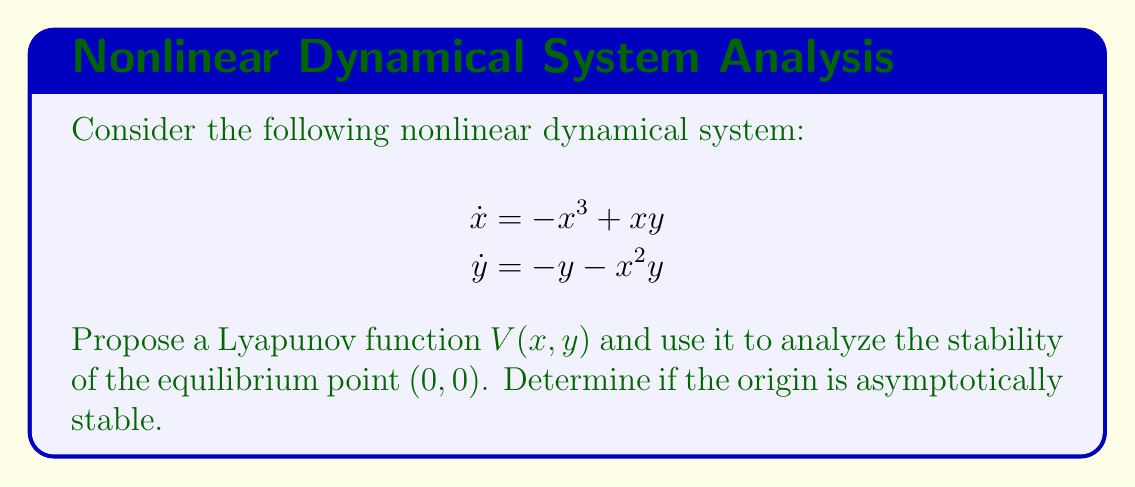Can you solve this math problem? To analyze the stability of the nonlinear dynamical system using Lyapunov functions, we'll follow these steps:

1) Propose a Lyapunov function $V(x,y)$:
   Let's choose $V(x,y) = \frac{1}{2}(x^2 + y^2)$

2) Check if $V(x,y)$ is positive definite:
   $V(x,y) = \frac{1}{2}(x^2 + y^2) > 0$ for all $(x,y) \neq (0,0)$, and $V(0,0) = 0$
   So, $V(x,y)$ is positive definite.

3) Calculate $\dot{V}(x,y)$:
   $$\begin{aligned}
   \dot{V}(x,y) &= \frac{\partial V}{\partial x}\dot{x} + \frac{\partial V}{\partial y}\dot{y} \\
   &= x(-x^3 + xy) + y(-y - x^2y) \\
   &= -x^4 + x^2y - y^2 - x^2y^2 \\
   &= -x^4 - y^2 - x^2y^2 + x^2y
   \end{aligned}$$

4) Analyze $\dot{V}(x,y)$:
   We need to show that $\dot{V}(x,y) < 0$ for all $(x,y) \neq (0,0)$
   
   Rearranging terms: $\dot{V}(x,y) = -(x^4 + y^2) - x^2y^2 + x^2y$
   
   Using the inequality $ab \leq \frac{a^2 + b^2}{2}$, we have:
   $x^2y \leq \frac{x^4 + y^2}{2}$

   Therefore,
   $$\begin{aligned}
   \dot{V}(x,y) &\leq -(x^4 + y^2) - x^2y^2 + \frac{x^4 + y^2}{2} \\
   &= -\frac{1}{2}(x^4 + y^2) - x^2y^2 \\
   &< 0
   \end{aligned}$$
   for all $(x,y) \neq (0,0)$

5) Conclusion:
   Since $V(x,y)$ is positive definite and $\dot{V}(x,y)$ is negative definite, by Lyapunov's stability theorem, the equilibrium point $(0,0)$ is asymptotically stable.
Answer: The origin $(0,0)$ is asymptotically stable. 